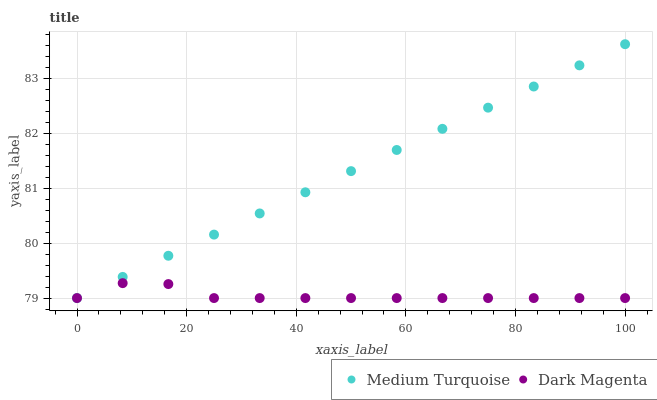Does Dark Magenta have the minimum area under the curve?
Answer yes or no. Yes. Does Medium Turquoise have the maximum area under the curve?
Answer yes or no. Yes. Does Medium Turquoise have the minimum area under the curve?
Answer yes or no. No. Is Medium Turquoise the smoothest?
Answer yes or no. Yes. Is Dark Magenta the roughest?
Answer yes or no. Yes. Is Medium Turquoise the roughest?
Answer yes or no. No. Does Dark Magenta have the lowest value?
Answer yes or no. Yes. Does Medium Turquoise have the highest value?
Answer yes or no. Yes. Does Medium Turquoise intersect Dark Magenta?
Answer yes or no. Yes. Is Medium Turquoise less than Dark Magenta?
Answer yes or no. No. Is Medium Turquoise greater than Dark Magenta?
Answer yes or no. No. 